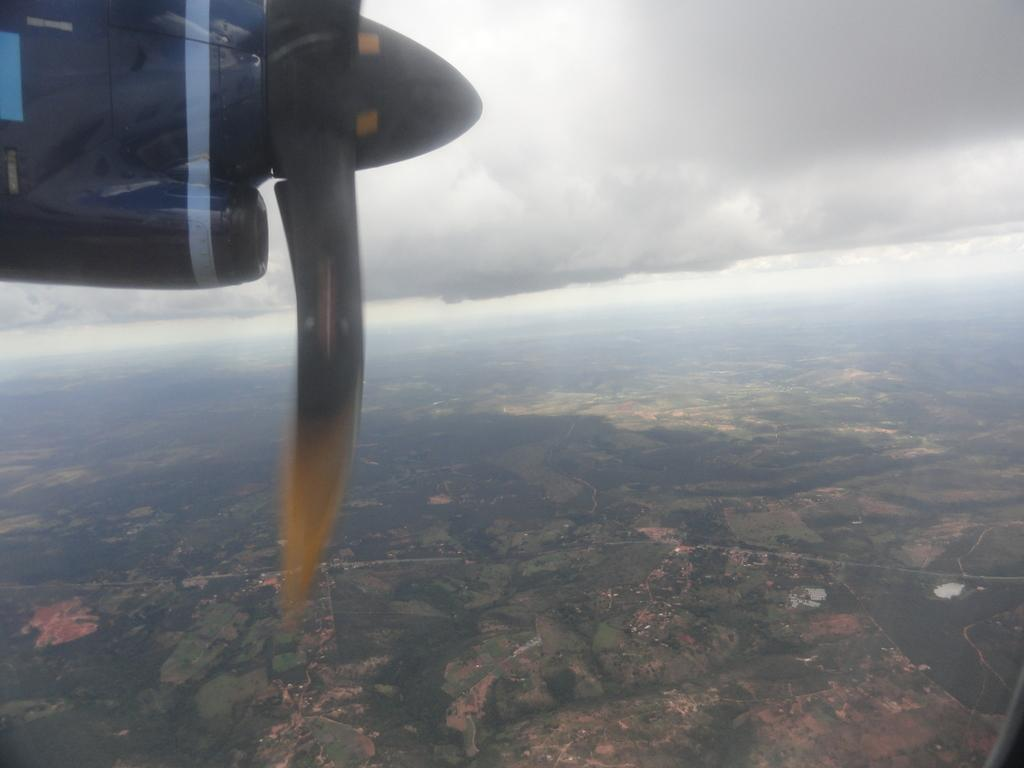What is the main subject of the picture? The main subject of the picture is an aircraft. What other elements can be seen in the image? There are trees and buildings in the image. Where is the aircraft located in the image? The aircraft is on the floor, which likely means it's on the ground. What type of flowers can be seen in the image? There are no flowers present in the image. 